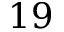<formula> <loc_0><loc_0><loc_500><loc_500>1 9</formula> 